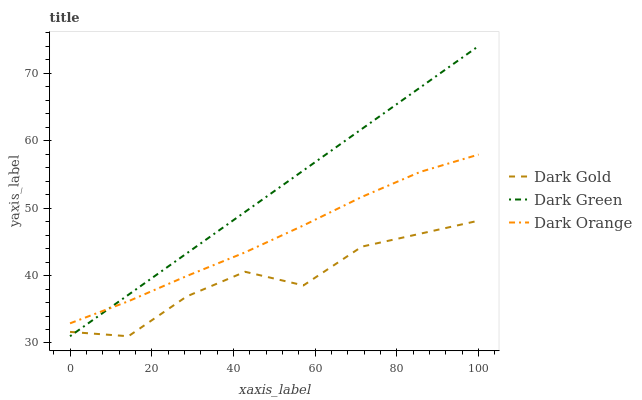Does Dark Gold have the minimum area under the curve?
Answer yes or no. Yes. Does Dark Green have the maximum area under the curve?
Answer yes or no. Yes. Does Dark Green have the minimum area under the curve?
Answer yes or no. No. Does Dark Gold have the maximum area under the curve?
Answer yes or no. No. Is Dark Green the smoothest?
Answer yes or no. Yes. Is Dark Gold the roughest?
Answer yes or no. Yes. Is Dark Gold the smoothest?
Answer yes or no. No. Is Dark Green the roughest?
Answer yes or no. No. Does Dark Green have the lowest value?
Answer yes or no. Yes. Does Dark Green have the highest value?
Answer yes or no. Yes. Does Dark Gold have the highest value?
Answer yes or no. No. Is Dark Gold less than Dark Orange?
Answer yes or no. Yes. Is Dark Orange greater than Dark Gold?
Answer yes or no. Yes. Does Dark Gold intersect Dark Green?
Answer yes or no. Yes. Is Dark Gold less than Dark Green?
Answer yes or no. No. Is Dark Gold greater than Dark Green?
Answer yes or no. No. Does Dark Gold intersect Dark Orange?
Answer yes or no. No. 